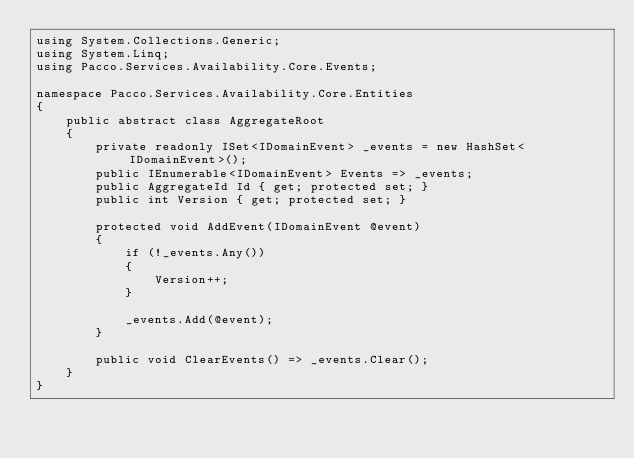<code> <loc_0><loc_0><loc_500><loc_500><_C#_>using System.Collections.Generic;
using System.Linq;
using Pacco.Services.Availability.Core.Events;

namespace Pacco.Services.Availability.Core.Entities
{
    public abstract class AggregateRoot
    {
        private readonly ISet<IDomainEvent> _events = new HashSet<IDomainEvent>();
        public IEnumerable<IDomainEvent> Events => _events;
        public AggregateId Id { get; protected set; }
        public int Version { get; protected set; }

        protected void AddEvent(IDomainEvent @event)
        {
            if (!_events.Any())
            {
                Version++;
            }

            _events.Add(@event);
        }

        public void ClearEvents() => _events.Clear();
    }
}</code> 